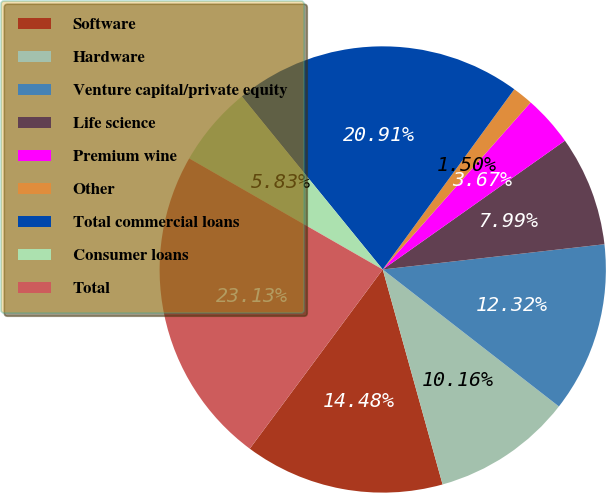Convert chart to OTSL. <chart><loc_0><loc_0><loc_500><loc_500><pie_chart><fcel>Software<fcel>Hardware<fcel>Venture capital/private equity<fcel>Life science<fcel>Premium wine<fcel>Other<fcel>Total commercial loans<fcel>Consumer loans<fcel>Total<nl><fcel>14.48%<fcel>10.16%<fcel>12.32%<fcel>7.99%<fcel>3.67%<fcel>1.5%<fcel>20.91%<fcel>5.83%<fcel>23.13%<nl></chart> 